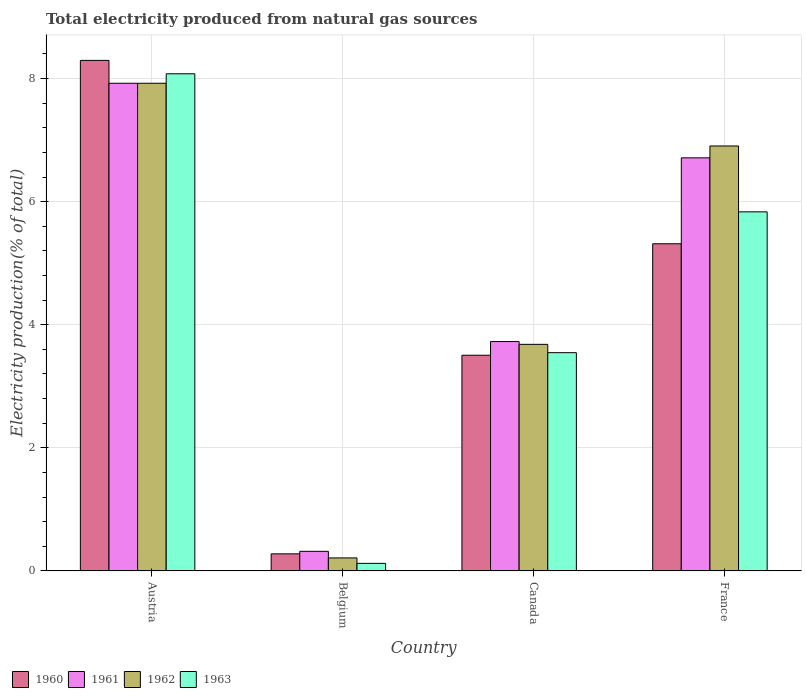How many groups of bars are there?
Provide a short and direct response. 4. How many bars are there on the 3rd tick from the left?
Your answer should be very brief. 4. How many bars are there on the 3rd tick from the right?
Make the answer very short. 4. What is the total electricity produced in 1962 in France?
Your answer should be compact. 6.91. Across all countries, what is the maximum total electricity produced in 1962?
Your answer should be very brief. 7.92. Across all countries, what is the minimum total electricity produced in 1962?
Your answer should be compact. 0.21. In which country was the total electricity produced in 1961 maximum?
Ensure brevity in your answer.  Austria. In which country was the total electricity produced in 1963 minimum?
Ensure brevity in your answer.  Belgium. What is the total total electricity produced in 1963 in the graph?
Your answer should be very brief. 17.58. What is the difference between the total electricity produced in 1962 in Austria and that in Belgium?
Provide a short and direct response. 7.71. What is the difference between the total electricity produced in 1962 in Austria and the total electricity produced in 1963 in Belgium?
Offer a terse response. 7.8. What is the average total electricity produced in 1960 per country?
Your answer should be very brief. 4.35. What is the difference between the total electricity produced of/in 1962 and total electricity produced of/in 1963 in France?
Make the answer very short. 1.07. In how many countries, is the total electricity produced in 1962 greater than 7.2 %?
Ensure brevity in your answer.  1. What is the ratio of the total electricity produced in 1961 in Austria to that in France?
Your answer should be very brief. 1.18. What is the difference between the highest and the second highest total electricity produced in 1963?
Provide a short and direct response. 4.53. What is the difference between the highest and the lowest total electricity produced in 1960?
Give a very brief answer. 8.02. In how many countries, is the total electricity produced in 1960 greater than the average total electricity produced in 1960 taken over all countries?
Provide a short and direct response. 2. What does the 2nd bar from the left in France represents?
Provide a succinct answer. 1961. What does the 4th bar from the right in Belgium represents?
Give a very brief answer. 1960. How many countries are there in the graph?
Offer a terse response. 4. Does the graph contain any zero values?
Give a very brief answer. No. Does the graph contain grids?
Provide a succinct answer. Yes. How many legend labels are there?
Your answer should be very brief. 4. What is the title of the graph?
Your answer should be compact. Total electricity produced from natural gas sources. What is the Electricity production(% of total) in 1960 in Austria?
Provide a short and direct response. 8.3. What is the Electricity production(% of total) of 1961 in Austria?
Offer a terse response. 7.92. What is the Electricity production(% of total) in 1962 in Austria?
Provide a short and direct response. 7.92. What is the Electricity production(% of total) in 1963 in Austria?
Your answer should be compact. 8.08. What is the Electricity production(% of total) in 1960 in Belgium?
Ensure brevity in your answer.  0.28. What is the Electricity production(% of total) of 1961 in Belgium?
Give a very brief answer. 0.32. What is the Electricity production(% of total) in 1962 in Belgium?
Your answer should be very brief. 0.21. What is the Electricity production(% of total) of 1963 in Belgium?
Your answer should be very brief. 0.12. What is the Electricity production(% of total) in 1960 in Canada?
Offer a terse response. 3.5. What is the Electricity production(% of total) in 1961 in Canada?
Provide a short and direct response. 3.73. What is the Electricity production(% of total) of 1962 in Canada?
Provide a short and direct response. 3.68. What is the Electricity production(% of total) of 1963 in Canada?
Make the answer very short. 3.55. What is the Electricity production(% of total) in 1960 in France?
Offer a terse response. 5.32. What is the Electricity production(% of total) of 1961 in France?
Give a very brief answer. 6.71. What is the Electricity production(% of total) of 1962 in France?
Provide a succinct answer. 6.91. What is the Electricity production(% of total) of 1963 in France?
Give a very brief answer. 5.83. Across all countries, what is the maximum Electricity production(% of total) of 1960?
Provide a short and direct response. 8.3. Across all countries, what is the maximum Electricity production(% of total) of 1961?
Ensure brevity in your answer.  7.92. Across all countries, what is the maximum Electricity production(% of total) in 1962?
Make the answer very short. 7.92. Across all countries, what is the maximum Electricity production(% of total) in 1963?
Your answer should be compact. 8.08. Across all countries, what is the minimum Electricity production(% of total) of 1960?
Ensure brevity in your answer.  0.28. Across all countries, what is the minimum Electricity production(% of total) in 1961?
Offer a very short reply. 0.32. Across all countries, what is the minimum Electricity production(% of total) of 1962?
Ensure brevity in your answer.  0.21. Across all countries, what is the minimum Electricity production(% of total) in 1963?
Offer a very short reply. 0.12. What is the total Electricity production(% of total) in 1960 in the graph?
Your answer should be very brief. 17.39. What is the total Electricity production(% of total) in 1961 in the graph?
Your answer should be compact. 18.68. What is the total Electricity production(% of total) in 1962 in the graph?
Give a very brief answer. 18.72. What is the total Electricity production(% of total) of 1963 in the graph?
Your response must be concise. 17.58. What is the difference between the Electricity production(% of total) in 1960 in Austria and that in Belgium?
Give a very brief answer. 8.02. What is the difference between the Electricity production(% of total) in 1961 in Austria and that in Belgium?
Your answer should be very brief. 7.61. What is the difference between the Electricity production(% of total) of 1962 in Austria and that in Belgium?
Provide a succinct answer. 7.71. What is the difference between the Electricity production(% of total) of 1963 in Austria and that in Belgium?
Give a very brief answer. 7.96. What is the difference between the Electricity production(% of total) in 1960 in Austria and that in Canada?
Your response must be concise. 4.79. What is the difference between the Electricity production(% of total) of 1961 in Austria and that in Canada?
Provide a succinct answer. 4.2. What is the difference between the Electricity production(% of total) in 1962 in Austria and that in Canada?
Your response must be concise. 4.24. What is the difference between the Electricity production(% of total) of 1963 in Austria and that in Canada?
Provide a short and direct response. 4.53. What is the difference between the Electricity production(% of total) of 1960 in Austria and that in France?
Keep it short and to the point. 2.98. What is the difference between the Electricity production(% of total) in 1961 in Austria and that in France?
Offer a terse response. 1.21. What is the difference between the Electricity production(% of total) of 1962 in Austria and that in France?
Keep it short and to the point. 1.02. What is the difference between the Electricity production(% of total) in 1963 in Austria and that in France?
Your answer should be very brief. 2.24. What is the difference between the Electricity production(% of total) of 1960 in Belgium and that in Canada?
Offer a terse response. -3.23. What is the difference between the Electricity production(% of total) in 1961 in Belgium and that in Canada?
Your answer should be very brief. -3.41. What is the difference between the Electricity production(% of total) in 1962 in Belgium and that in Canada?
Your answer should be compact. -3.47. What is the difference between the Electricity production(% of total) in 1963 in Belgium and that in Canada?
Your answer should be compact. -3.42. What is the difference between the Electricity production(% of total) of 1960 in Belgium and that in France?
Make the answer very short. -5.04. What is the difference between the Electricity production(% of total) in 1961 in Belgium and that in France?
Your answer should be compact. -6.39. What is the difference between the Electricity production(% of total) in 1962 in Belgium and that in France?
Offer a very short reply. -6.69. What is the difference between the Electricity production(% of total) of 1963 in Belgium and that in France?
Your response must be concise. -5.71. What is the difference between the Electricity production(% of total) in 1960 in Canada and that in France?
Offer a terse response. -1.81. What is the difference between the Electricity production(% of total) of 1961 in Canada and that in France?
Give a very brief answer. -2.99. What is the difference between the Electricity production(% of total) of 1962 in Canada and that in France?
Your answer should be compact. -3.22. What is the difference between the Electricity production(% of total) in 1963 in Canada and that in France?
Offer a very short reply. -2.29. What is the difference between the Electricity production(% of total) of 1960 in Austria and the Electricity production(% of total) of 1961 in Belgium?
Your answer should be compact. 7.98. What is the difference between the Electricity production(% of total) of 1960 in Austria and the Electricity production(% of total) of 1962 in Belgium?
Provide a succinct answer. 8.08. What is the difference between the Electricity production(% of total) in 1960 in Austria and the Electricity production(% of total) in 1963 in Belgium?
Give a very brief answer. 8.17. What is the difference between the Electricity production(% of total) in 1961 in Austria and the Electricity production(% of total) in 1962 in Belgium?
Offer a terse response. 7.71. What is the difference between the Electricity production(% of total) of 1961 in Austria and the Electricity production(% of total) of 1963 in Belgium?
Your answer should be very brief. 7.8. What is the difference between the Electricity production(% of total) in 1962 in Austria and the Electricity production(% of total) in 1963 in Belgium?
Keep it short and to the point. 7.8. What is the difference between the Electricity production(% of total) in 1960 in Austria and the Electricity production(% of total) in 1961 in Canada?
Your answer should be very brief. 4.57. What is the difference between the Electricity production(% of total) of 1960 in Austria and the Electricity production(% of total) of 1962 in Canada?
Provide a succinct answer. 4.61. What is the difference between the Electricity production(% of total) in 1960 in Austria and the Electricity production(% of total) in 1963 in Canada?
Offer a very short reply. 4.75. What is the difference between the Electricity production(% of total) of 1961 in Austria and the Electricity production(% of total) of 1962 in Canada?
Ensure brevity in your answer.  4.24. What is the difference between the Electricity production(% of total) of 1961 in Austria and the Electricity production(% of total) of 1963 in Canada?
Provide a succinct answer. 4.38. What is the difference between the Electricity production(% of total) of 1962 in Austria and the Electricity production(% of total) of 1963 in Canada?
Provide a succinct answer. 4.38. What is the difference between the Electricity production(% of total) in 1960 in Austria and the Electricity production(% of total) in 1961 in France?
Keep it short and to the point. 1.58. What is the difference between the Electricity production(% of total) of 1960 in Austria and the Electricity production(% of total) of 1962 in France?
Provide a short and direct response. 1.39. What is the difference between the Electricity production(% of total) of 1960 in Austria and the Electricity production(% of total) of 1963 in France?
Offer a terse response. 2.46. What is the difference between the Electricity production(% of total) in 1961 in Austria and the Electricity production(% of total) in 1962 in France?
Ensure brevity in your answer.  1.02. What is the difference between the Electricity production(% of total) in 1961 in Austria and the Electricity production(% of total) in 1963 in France?
Keep it short and to the point. 2.09. What is the difference between the Electricity production(% of total) in 1962 in Austria and the Electricity production(% of total) in 1963 in France?
Your response must be concise. 2.09. What is the difference between the Electricity production(% of total) of 1960 in Belgium and the Electricity production(% of total) of 1961 in Canada?
Your response must be concise. -3.45. What is the difference between the Electricity production(% of total) in 1960 in Belgium and the Electricity production(% of total) in 1962 in Canada?
Ensure brevity in your answer.  -3.4. What is the difference between the Electricity production(% of total) in 1960 in Belgium and the Electricity production(% of total) in 1963 in Canada?
Your answer should be very brief. -3.27. What is the difference between the Electricity production(% of total) in 1961 in Belgium and the Electricity production(% of total) in 1962 in Canada?
Give a very brief answer. -3.36. What is the difference between the Electricity production(% of total) of 1961 in Belgium and the Electricity production(% of total) of 1963 in Canada?
Provide a short and direct response. -3.23. What is the difference between the Electricity production(% of total) of 1962 in Belgium and the Electricity production(% of total) of 1963 in Canada?
Provide a short and direct response. -3.34. What is the difference between the Electricity production(% of total) in 1960 in Belgium and the Electricity production(% of total) in 1961 in France?
Offer a very short reply. -6.43. What is the difference between the Electricity production(% of total) of 1960 in Belgium and the Electricity production(% of total) of 1962 in France?
Keep it short and to the point. -6.63. What is the difference between the Electricity production(% of total) in 1960 in Belgium and the Electricity production(% of total) in 1963 in France?
Provide a short and direct response. -5.56. What is the difference between the Electricity production(% of total) of 1961 in Belgium and the Electricity production(% of total) of 1962 in France?
Your answer should be compact. -6.59. What is the difference between the Electricity production(% of total) in 1961 in Belgium and the Electricity production(% of total) in 1963 in France?
Your response must be concise. -5.52. What is the difference between the Electricity production(% of total) in 1962 in Belgium and the Electricity production(% of total) in 1963 in France?
Your answer should be compact. -5.62. What is the difference between the Electricity production(% of total) in 1960 in Canada and the Electricity production(% of total) in 1961 in France?
Offer a very short reply. -3.21. What is the difference between the Electricity production(% of total) of 1960 in Canada and the Electricity production(% of total) of 1962 in France?
Offer a terse response. -3.4. What is the difference between the Electricity production(% of total) of 1960 in Canada and the Electricity production(% of total) of 1963 in France?
Provide a succinct answer. -2.33. What is the difference between the Electricity production(% of total) of 1961 in Canada and the Electricity production(% of total) of 1962 in France?
Ensure brevity in your answer.  -3.18. What is the difference between the Electricity production(% of total) of 1961 in Canada and the Electricity production(% of total) of 1963 in France?
Your response must be concise. -2.11. What is the difference between the Electricity production(% of total) in 1962 in Canada and the Electricity production(% of total) in 1963 in France?
Keep it short and to the point. -2.15. What is the average Electricity production(% of total) of 1960 per country?
Keep it short and to the point. 4.35. What is the average Electricity production(% of total) in 1961 per country?
Provide a short and direct response. 4.67. What is the average Electricity production(% of total) in 1962 per country?
Keep it short and to the point. 4.68. What is the average Electricity production(% of total) in 1963 per country?
Your response must be concise. 4.4. What is the difference between the Electricity production(% of total) in 1960 and Electricity production(% of total) in 1961 in Austria?
Ensure brevity in your answer.  0.37. What is the difference between the Electricity production(% of total) of 1960 and Electricity production(% of total) of 1962 in Austria?
Offer a very short reply. 0.37. What is the difference between the Electricity production(% of total) of 1960 and Electricity production(% of total) of 1963 in Austria?
Ensure brevity in your answer.  0.22. What is the difference between the Electricity production(% of total) of 1961 and Electricity production(% of total) of 1963 in Austria?
Offer a terse response. -0.15. What is the difference between the Electricity production(% of total) of 1962 and Electricity production(% of total) of 1963 in Austria?
Your answer should be compact. -0.15. What is the difference between the Electricity production(% of total) of 1960 and Electricity production(% of total) of 1961 in Belgium?
Provide a short and direct response. -0.04. What is the difference between the Electricity production(% of total) of 1960 and Electricity production(% of total) of 1962 in Belgium?
Give a very brief answer. 0.07. What is the difference between the Electricity production(% of total) of 1960 and Electricity production(% of total) of 1963 in Belgium?
Your answer should be very brief. 0.15. What is the difference between the Electricity production(% of total) in 1961 and Electricity production(% of total) in 1962 in Belgium?
Provide a succinct answer. 0.11. What is the difference between the Electricity production(% of total) of 1961 and Electricity production(% of total) of 1963 in Belgium?
Provide a short and direct response. 0.2. What is the difference between the Electricity production(% of total) of 1962 and Electricity production(% of total) of 1963 in Belgium?
Offer a terse response. 0.09. What is the difference between the Electricity production(% of total) in 1960 and Electricity production(% of total) in 1961 in Canada?
Give a very brief answer. -0.22. What is the difference between the Electricity production(% of total) in 1960 and Electricity production(% of total) in 1962 in Canada?
Your answer should be very brief. -0.18. What is the difference between the Electricity production(% of total) in 1960 and Electricity production(% of total) in 1963 in Canada?
Provide a succinct answer. -0.04. What is the difference between the Electricity production(% of total) of 1961 and Electricity production(% of total) of 1962 in Canada?
Offer a terse response. 0.05. What is the difference between the Electricity production(% of total) of 1961 and Electricity production(% of total) of 1963 in Canada?
Provide a succinct answer. 0.18. What is the difference between the Electricity production(% of total) in 1962 and Electricity production(% of total) in 1963 in Canada?
Offer a very short reply. 0.14. What is the difference between the Electricity production(% of total) in 1960 and Electricity production(% of total) in 1961 in France?
Your response must be concise. -1.4. What is the difference between the Electricity production(% of total) in 1960 and Electricity production(% of total) in 1962 in France?
Give a very brief answer. -1.59. What is the difference between the Electricity production(% of total) of 1960 and Electricity production(% of total) of 1963 in France?
Ensure brevity in your answer.  -0.52. What is the difference between the Electricity production(% of total) in 1961 and Electricity production(% of total) in 1962 in France?
Provide a short and direct response. -0.19. What is the difference between the Electricity production(% of total) in 1961 and Electricity production(% of total) in 1963 in France?
Offer a terse response. 0.88. What is the difference between the Electricity production(% of total) in 1962 and Electricity production(% of total) in 1963 in France?
Offer a terse response. 1.07. What is the ratio of the Electricity production(% of total) of 1960 in Austria to that in Belgium?
Your answer should be very brief. 29.93. What is the ratio of the Electricity production(% of total) in 1961 in Austria to that in Belgium?
Offer a terse response. 24.9. What is the ratio of the Electricity production(% of total) in 1962 in Austria to that in Belgium?
Your response must be concise. 37.57. What is the ratio of the Electricity production(% of total) in 1963 in Austria to that in Belgium?
Provide a succinct answer. 66.07. What is the ratio of the Electricity production(% of total) of 1960 in Austria to that in Canada?
Ensure brevity in your answer.  2.37. What is the ratio of the Electricity production(% of total) of 1961 in Austria to that in Canada?
Provide a short and direct response. 2.13. What is the ratio of the Electricity production(% of total) in 1962 in Austria to that in Canada?
Make the answer very short. 2.15. What is the ratio of the Electricity production(% of total) of 1963 in Austria to that in Canada?
Provide a succinct answer. 2.28. What is the ratio of the Electricity production(% of total) in 1960 in Austria to that in France?
Offer a very short reply. 1.56. What is the ratio of the Electricity production(% of total) of 1961 in Austria to that in France?
Ensure brevity in your answer.  1.18. What is the ratio of the Electricity production(% of total) of 1962 in Austria to that in France?
Ensure brevity in your answer.  1.15. What is the ratio of the Electricity production(% of total) in 1963 in Austria to that in France?
Your response must be concise. 1.38. What is the ratio of the Electricity production(% of total) of 1960 in Belgium to that in Canada?
Provide a succinct answer. 0.08. What is the ratio of the Electricity production(% of total) of 1961 in Belgium to that in Canada?
Ensure brevity in your answer.  0.09. What is the ratio of the Electricity production(% of total) of 1962 in Belgium to that in Canada?
Offer a very short reply. 0.06. What is the ratio of the Electricity production(% of total) of 1963 in Belgium to that in Canada?
Give a very brief answer. 0.03. What is the ratio of the Electricity production(% of total) of 1960 in Belgium to that in France?
Provide a succinct answer. 0.05. What is the ratio of the Electricity production(% of total) of 1961 in Belgium to that in France?
Offer a terse response. 0.05. What is the ratio of the Electricity production(% of total) in 1962 in Belgium to that in France?
Make the answer very short. 0.03. What is the ratio of the Electricity production(% of total) in 1963 in Belgium to that in France?
Keep it short and to the point. 0.02. What is the ratio of the Electricity production(% of total) of 1960 in Canada to that in France?
Your answer should be very brief. 0.66. What is the ratio of the Electricity production(% of total) of 1961 in Canada to that in France?
Provide a short and direct response. 0.56. What is the ratio of the Electricity production(% of total) in 1962 in Canada to that in France?
Provide a short and direct response. 0.53. What is the ratio of the Electricity production(% of total) of 1963 in Canada to that in France?
Ensure brevity in your answer.  0.61. What is the difference between the highest and the second highest Electricity production(% of total) in 1960?
Your answer should be compact. 2.98. What is the difference between the highest and the second highest Electricity production(% of total) of 1961?
Ensure brevity in your answer.  1.21. What is the difference between the highest and the second highest Electricity production(% of total) of 1963?
Make the answer very short. 2.24. What is the difference between the highest and the lowest Electricity production(% of total) in 1960?
Your answer should be very brief. 8.02. What is the difference between the highest and the lowest Electricity production(% of total) of 1961?
Your answer should be very brief. 7.61. What is the difference between the highest and the lowest Electricity production(% of total) in 1962?
Ensure brevity in your answer.  7.71. What is the difference between the highest and the lowest Electricity production(% of total) of 1963?
Offer a very short reply. 7.96. 